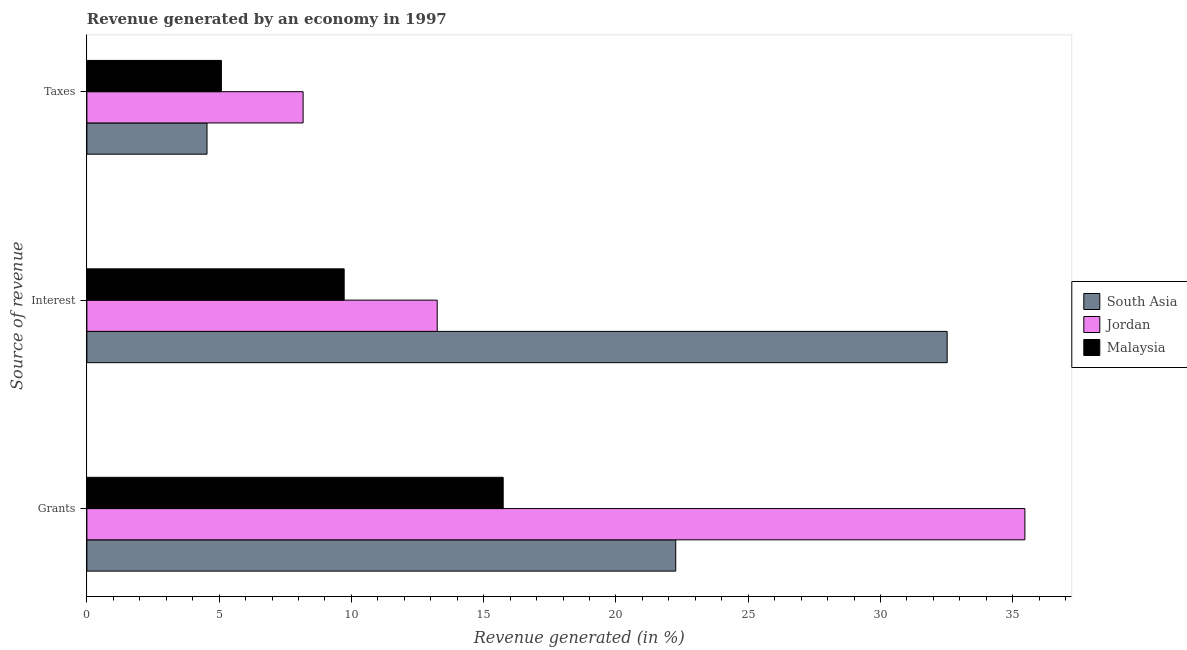How many different coloured bars are there?
Keep it short and to the point. 3. How many bars are there on the 2nd tick from the top?
Your response must be concise. 3. How many bars are there on the 1st tick from the bottom?
Your answer should be very brief. 3. What is the label of the 1st group of bars from the top?
Keep it short and to the point. Taxes. What is the percentage of revenue generated by interest in Malaysia?
Ensure brevity in your answer.  9.73. Across all countries, what is the maximum percentage of revenue generated by interest?
Provide a succinct answer. 32.52. Across all countries, what is the minimum percentage of revenue generated by interest?
Offer a terse response. 9.73. In which country was the percentage of revenue generated by grants maximum?
Ensure brevity in your answer.  Jordan. In which country was the percentage of revenue generated by interest minimum?
Offer a very short reply. Malaysia. What is the total percentage of revenue generated by grants in the graph?
Keep it short and to the point. 73.46. What is the difference between the percentage of revenue generated by interest in South Asia and that in Malaysia?
Your response must be concise. 22.79. What is the difference between the percentage of revenue generated by grants in Malaysia and the percentage of revenue generated by interest in Jordan?
Your response must be concise. 2.49. What is the average percentage of revenue generated by interest per country?
Offer a terse response. 18.5. What is the difference between the percentage of revenue generated by taxes and percentage of revenue generated by interest in Malaysia?
Keep it short and to the point. -4.64. In how many countries, is the percentage of revenue generated by grants greater than 9 %?
Offer a very short reply. 3. What is the ratio of the percentage of revenue generated by interest in Jordan to that in Malaysia?
Your response must be concise. 1.36. Is the percentage of revenue generated by grants in Jordan less than that in South Asia?
Offer a very short reply. No. What is the difference between the highest and the second highest percentage of revenue generated by taxes?
Give a very brief answer. 3.09. What is the difference between the highest and the lowest percentage of revenue generated by interest?
Make the answer very short. 22.79. Is the sum of the percentage of revenue generated by taxes in South Asia and Malaysia greater than the maximum percentage of revenue generated by interest across all countries?
Provide a succinct answer. No. What does the 3rd bar from the top in Grants represents?
Give a very brief answer. South Asia. What does the 2nd bar from the bottom in Grants represents?
Ensure brevity in your answer.  Jordan. Is it the case that in every country, the sum of the percentage of revenue generated by grants and percentage of revenue generated by interest is greater than the percentage of revenue generated by taxes?
Offer a very short reply. Yes. How many bars are there?
Your answer should be compact. 9. How many countries are there in the graph?
Your answer should be compact. 3. What is the difference between two consecutive major ticks on the X-axis?
Make the answer very short. 5. Does the graph contain any zero values?
Offer a very short reply. No. How many legend labels are there?
Ensure brevity in your answer.  3. What is the title of the graph?
Make the answer very short. Revenue generated by an economy in 1997. Does "Japan" appear as one of the legend labels in the graph?
Keep it short and to the point. No. What is the label or title of the X-axis?
Offer a terse response. Revenue generated (in %). What is the label or title of the Y-axis?
Ensure brevity in your answer.  Source of revenue. What is the Revenue generated (in %) in South Asia in Grants?
Your response must be concise. 22.26. What is the Revenue generated (in %) in Jordan in Grants?
Make the answer very short. 35.46. What is the Revenue generated (in %) of Malaysia in Grants?
Offer a terse response. 15.74. What is the Revenue generated (in %) in South Asia in Interest?
Your answer should be compact. 32.52. What is the Revenue generated (in %) of Jordan in Interest?
Provide a short and direct response. 13.24. What is the Revenue generated (in %) in Malaysia in Interest?
Your answer should be very brief. 9.73. What is the Revenue generated (in %) in South Asia in Taxes?
Provide a succinct answer. 4.54. What is the Revenue generated (in %) of Jordan in Taxes?
Offer a very short reply. 8.17. What is the Revenue generated (in %) in Malaysia in Taxes?
Keep it short and to the point. 5.08. Across all Source of revenue, what is the maximum Revenue generated (in %) of South Asia?
Make the answer very short. 32.52. Across all Source of revenue, what is the maximum Revenue generated (in %) of Jordan?
Ensure brevity in your answer.  35.46. Across all Source of revenue, what is the maximum Revenue generated (in %) of Malaysia?
Give a very brief answer. 15.74. Across all Source of revenue, what is the minimum Revenue generated (in %) in South Asia?
Offer a very short reply. 4.54. Across all Source of revenue, what is the minimum Revenue generated (in %) in Jordan?
Provide a succinct answer. 8.17. Across all Source of revenue, what is the minimum Revenue generated (in %) of Malaysia?
Your answer should be compact. 5.08. What is the total Revenue generated (in %) of South Asia in the graph?
Make the answer very short. 59.32. What is the total Revenue generated (in %) of Jordan in the graph?
Your answer should be compact. 56.87. What is the total Revenue generated (in %) in Malaysia in the graph?
Your answer should be compact. 30.55. What is the difference between the Revenue generated (in %) of South Asia in Grants and that in Interest?
Provide a succinct answer. -10.26. What is the difference between the Revenue generated (in %) in Jordan in Grants and that in Interest?
Offer a terse response. 22.22. What is the difference between the Revenue generated (in %) in Malaysia in Grants and that in Interest?
Give a very brief answer. 6.01. What is the difference between the Revenue generated (in %) in South Asia in Grants and that in Taxes?
Your answer should be very brief. 17.72. What is the difference between the Revenue generated (in %) of Jordan in Grants and that in Taxes?
Give a very brief answer. 27.28. What is the difference between the Revenue generated (in %) in Malaysia in Grants and that in Taxes?
Offer a terse response. 10.65. What is the difference between the Revenue generated (in %) of South Asia in Interest and that in Taxes?
Give a very brief answer. 27.98. What is the difference between the Revenue generated (in %) of Jordan in Interest and that in Taxes?
Your answer should be compact. 5.07. What is the difference between the Revenue generated (in %) in Malaysia in Interest and that in Taxes?
Offer a terse response. 4.64. What is the difference between the Revenue generated (in %) in South Asia in Grants and the Revenue generated (in %) in Jordan in Interest?
Give a very brief answer. 9.02. What is the difference between the Revenue generated (in %) in South Asia in Grants and the Revenue generated (in %) in Malaysia in Interest?
Provide a succinct answer. 12.53. What is the difference between the Revenue generated (in %) in Jordan in Grants and the Revenue generated (in %) in Malaysia in Interest?
Make the answer very short. 25.73. What is the difference between the Revenue generated (in %) in South Asia in Grants and the Revenue generated (in %) in Jordan in Taxes?
Your answer should be very brief. 14.09. What is the difference between the Revenue generated (in %) in South Asia in Grants and the Revenue generated (in %) in Malaysia in Taxes?
Your answer should be compact. 17.18. What is the difference between the Revenue generated (in %) of Jordan in Grants and the Revenue generated (in %) of Malaysia in Taxes?
Your response must be concise. 30.37. What is the difference between the Revenue generated (in %) of South Asia in Interest and the Revenue generated (in %) of Jordan in Taxes?
Offer a very short reply. 24.35. What is the difference between the Revenue generated (in %) of South Asia in Interest and the Revenue generated (in %) of Malaysia in Taxes?
Provide a succinct answer. 27.44. What is the difference between the Revenue generated (in %) in Jordan in Interest and the Revenue generated (in %) in Malaysia in Taxes?
Provide a short and direct response. 8.16. What is the average Revenue generated (in %) of South Asia per Source of revenue?
Your answer should be very brief. 19.77. What is the average Revenue generated (in %) of Jordan per Source of revenue?
Provide a short and direct response. 18.96. What is the average Revenue generated (in %) of Malaysia per Source of revenue?
Ensure brevity in your answer.  10.18. What is the difference between the Revenue generated (in %) of South Asia and Revenue generated (in %) of Jordan in Grants?
Offer a very short reply. -13.2. What is the difference between the Revenue generated (in %) of South Asia and Revenue generated (in %) of Malaysia in Grants?
Your answer should be very brief. 6.52. What is the difference between the Revenue generated (in %) of Jordan and Revenue generated (in %) of Malaysia in Grants?
Your answer should be compact. 19.72. What is the difference between the Revenue generated (in %) in South Asia and Revenue generated (in %) in Jordan in Interest?
Make the answer very short. 19.28. What is the difference between the Revenue generated (in %) of South Asia and Revenue generated (in %) of Malaysia in Interest?
Make the answer very short. 22.79. What is the difference between the Revenue generated (in %) in Jordan and Revenue generated (in %) in Malaysia in Interest?
Keep it short and to the point. 3.52. What is the difference between the Revenue generated (in %) of South Asia and Revenue generated (in %) of Jordan in Taxes?
Provide a succinct answer. -3.63. What is the difference between the Revenue generated (in %) in South Asia and Revenue generated (in %) in Malaysia in Taxes?
Your answer should be very brief. -0.54. What is the difference between the Revenue generated (in %) of Jordan and Revenue generated (in %) of Malaysia in Taxes?
Give a very brief answer. 3.09. What is the ratio of the Revenue generated (in %) in South Asia in Grants to that in Interest?
Make the answer very short. 0.68. What is the ratio of the Revenue generated (in %) in Jordan in Grants to that in Interest?
Keep it short and to the point. 2.68. What is the ratio of the Revenue generated (in %) in Malaysia in Grants to that in Interest?
Your answer should be very brief. 1.62. What is the ratio of the Revenue generated (in %) in South Asia in Grants to that in Taxes?
Your answer should be compact. 4.9. What is the ratio of the Revenue generated (in %) in Jordan in Grants to that in Taxes?
Ensure brevity in your answer.  4.34. What is the ratio of the Revenue generated (in %) in Malaysia in Grants to that in Taxes?
Offer a very short reply. 3.1. What is the ratio of the Revenue generated (in %) in South Asia in Interest to that in Taxes?
Keep it short and to the point. 7.16. What is the ratio of the Revenue generated (in %) in Jordan in Interest to that in Taxes?
Keep it short and to the point. 1.62. What is the ratio of the Revenue generated (in %) of Malaysia in Interest to that in Taxes?
Provide a succinct answer. 1.91. What is the difference between the highest and the second highest Revenue generated (in %) of South Asia?
Provide a short and direct response. 10.26. What is the difference between the highest and the second highest Revenue generated (in %) in Jordan?
Give a very brief answer. 22.22. What is the difference between the highest and the second highest Revenue generated (in %) in Malaysia?
Ensure brevity in your answer.  6.01. What is the difference between the highest and the lowest Revenue generated (in %) of South Asia?
Your response must be concise. 27.98. What is the difference between the highest and the lowest Revenue generated (in %) of Jordan?
Your response must be concise. 27.28. What is the difference between the highest and the lowest Revenue generated (in %) in Malaysia?
Offer a very short reply. 10.65. 